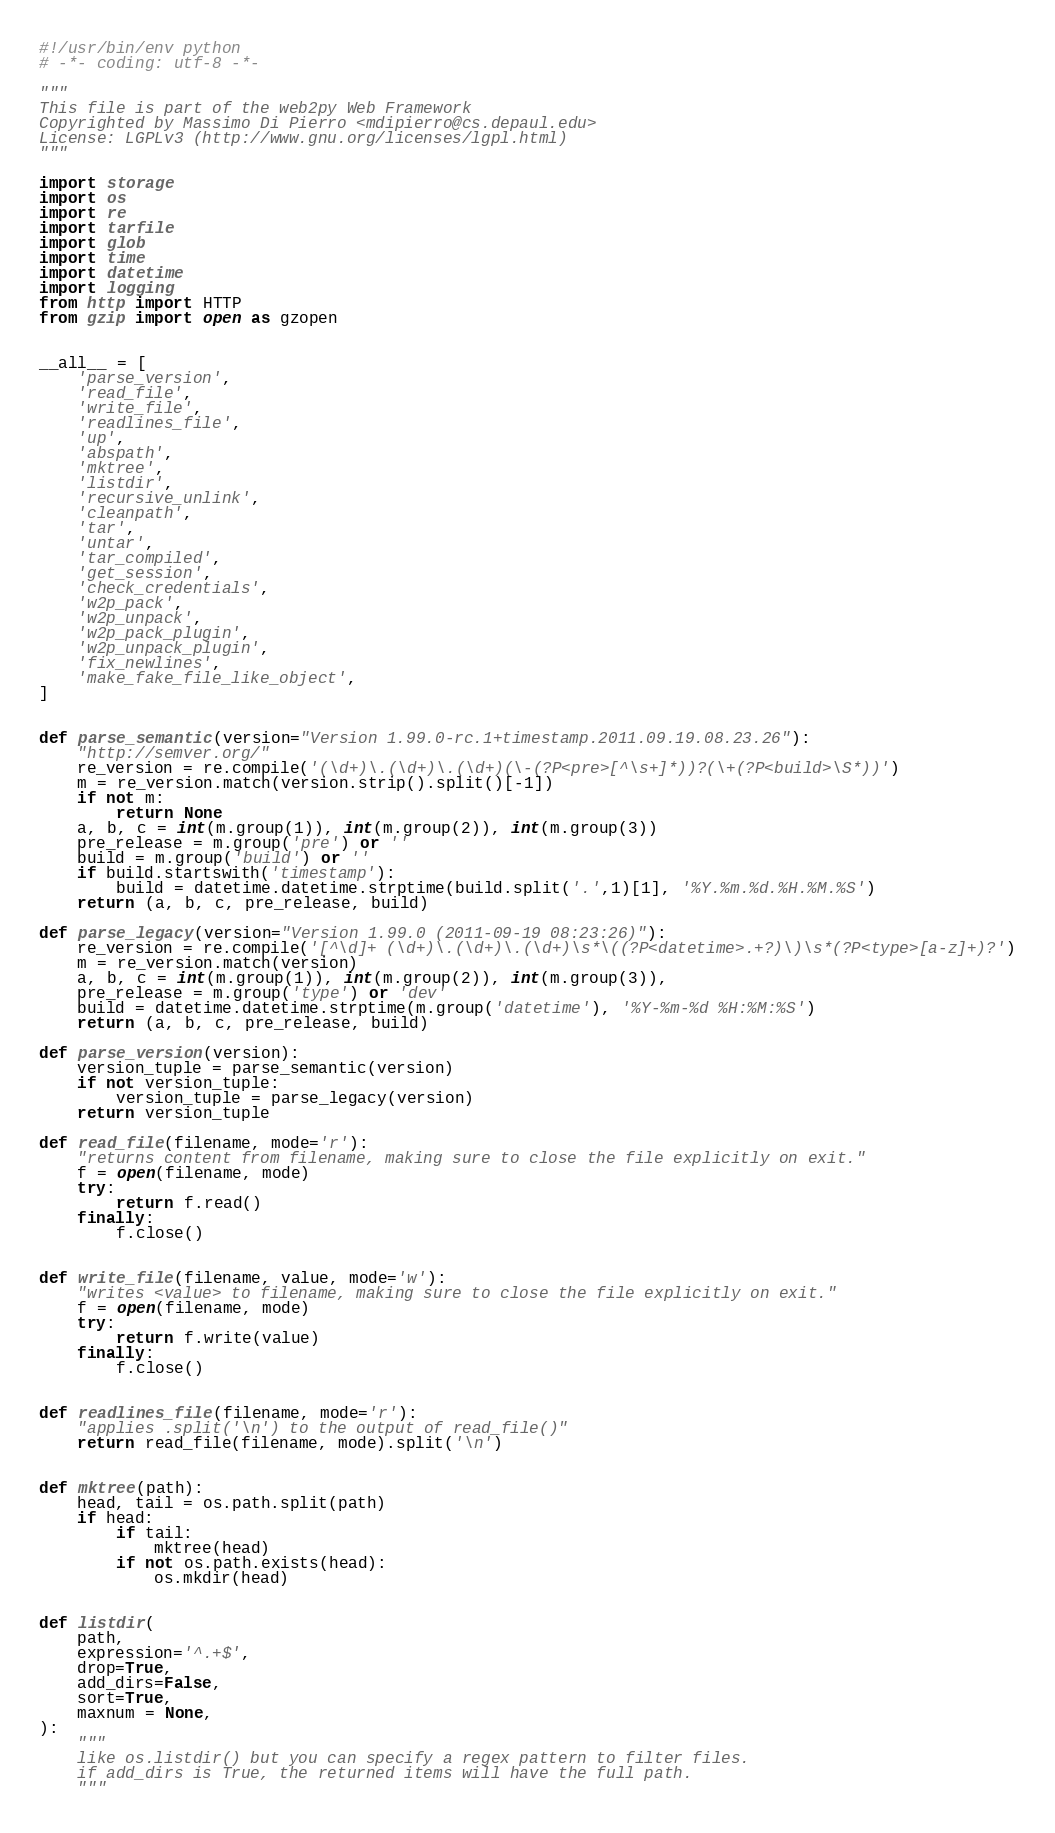Convert code to text. <code><loc_0><loc_0><loc_500><loc_500><_Python_>#!/usr/bin/env python
# -*- coding: utf-8 -*-

"""
This file is part of the web2py Web Framework
Copyrighted by Massimo Di Pierro <mdipierro@cs.depaul.edu>
License: LGPLv3 (http://www.gnu.org/licenses/lgpl.html)
"""

import storage
import os
import re
import tarfile
import glob
import time
import datetime
import logging
from http import HTTP
from gzip import open as gzopen


__all__ = [
    'parse_version',
    'read_file',
    'write_file',
    'readlines_file',
    'up',
    'abspath',
    'mktree',
    'listdir',
    'recursive_unlink',
    'cleanpath',
    'tar',
    'untar',
    'tar_compiled',
    'get_session',
    'check_credentials',
    'w2p_pack',
    'w2p_unpack',
    'w2p_pack_plugin',
    'w2p_unpack_plugin',
    'fix_newlines',
    'make_fake_file_like_object',
]


def parse_semantic(version="Version 1.99.0-rc.1+timestamp.2011.09.19.08.23.26"):
    "http://semver.org/"
    re_version = re.compile('(\d+)\.(\d+)\.(\d+)(\-(?P<pre>[^\s+]*))?(\+(?P<build>\S*))')
    m = re_version.match(version.strip().split()[-1])
    if not m:
        return None
    a, b, c = int(m.group(1)), int(m.group(2)), int(m.group(3))
    pre_release = m.group('pre') or ''
    build = m.group('build') or ''
    if build.startswith('timestamp'):
        build = datetime.datetime.strptime(build.split('.',1)[1], '%Y.%m.%d.%H.%M.%S')
    return (a, b, c, pre_release, build)

def parse_legacy(version="Version 1.99.0 (2011-09-19 08:23:26)"):
    re_version = re.compile('[^\d]+ (\d+)\.(\d+)\.(\d+)\s*\((?P<datetime>.+?)\)\s*(?P<type>[a-z]+)?')
    m = re_version.match(version)
    a, b, c = int(m.group(1)), int(m.group(2)), int(m.group(3)),
    pre_release = m.group('type') or 'dev'
    build = datetime.datetime.strptime(m.group('datetime'), '%Y-%m-%d %H:%M:%S')
    return (a, b, c, pre_release, build)

def parse_version(version):
    version_tuple = parse_semantic(version)
    if not version_tuple:
        version_tuple = parse_legacy(version)
    return version_tuple

def read_file(filename, mode='r'):
    "returns content from filename, making sure to close the file explicitly on exit."
    f = open(filename, mode)
    try:
        return f.read()
    finally:
        f.close()


def write_file(filename, value, mode='w'):
    "writes <value> to filename, making sure to close the file explicitly on exit."
    f = open(filename, mode)
    try:
        return f.write(value)
    finally:
        f.close()


def readlines_file(filename, mode='r'):
    "applies .split('\n') to the output of read_file()"
    return read_file(filename, mode).split('\n')


def mktree(path):
    head, tail = os.path.split(path)
    if head:
        if tail:
            mktree(head)
        if not os.path.exists(head):
            os.mkdir(head)


def listdir(
    path,
    expression='^.+$',
    drop=True,
    add_dirs=False,
    sort=True,
    maxnum = None,
):
    """
    like os.listdir() but you can specify a regex pattern to filter files.
    if add_dirs is True, the returned items will have the full path.
    """</code> 